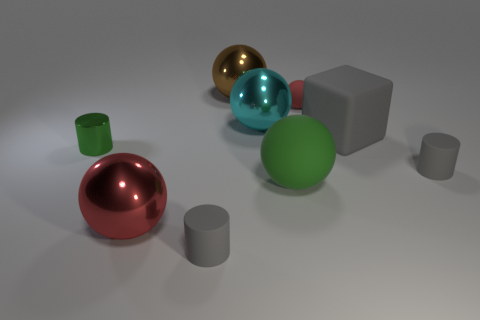Subtract all red balls. How many balls are left? 3 Subtract all cyan spheres. How many spheres are left? 4 Subtract all green spheres. Subtract all gray cylinders. How many spheres are left? 4 Add 1 brown rubber cylinders. How many objects exist? 10 Subtract all cylinders. How many objects are left? 6 Add 7 green cylinders. How many green cylinders exist? 8 Subtract 1 cyan spheres. How many objects are left? 8 Subtract all large cubes. Subtract all tiny gray metallic cylinders. How many objects are left? 8 Add 7 red matte things. How many red matte things are left? 8 